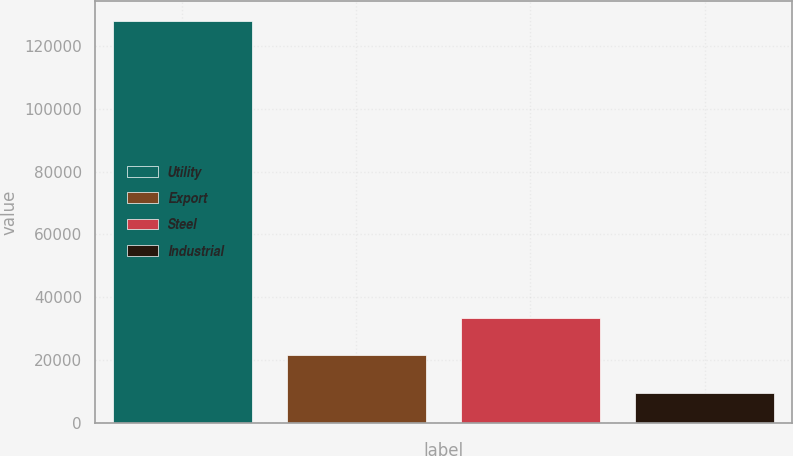<chart> <loc_0><loc_0><loc_500><loc_500><bar_chart><fcel>Utility<fcel>Export<fcel>Steel<fcel>Industrial<nl><fcel>127747<fcel>21534.4<fcel>33335.8<fcel>9733<nl></chart> 